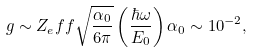Convert formula to latex. <formula><loc_0><loc_0><loc_500><loc_500>g \sim Z _ { e } f f \sqrt { \frac { \alpha _ { 0 } } { 6 \pi } } \left ( \frac { \hbar { \omega } } { E _ { 0 } } \right ) \alpha _ { 0 } \sim 1 0 ^ { - 2 } ,</formula> 